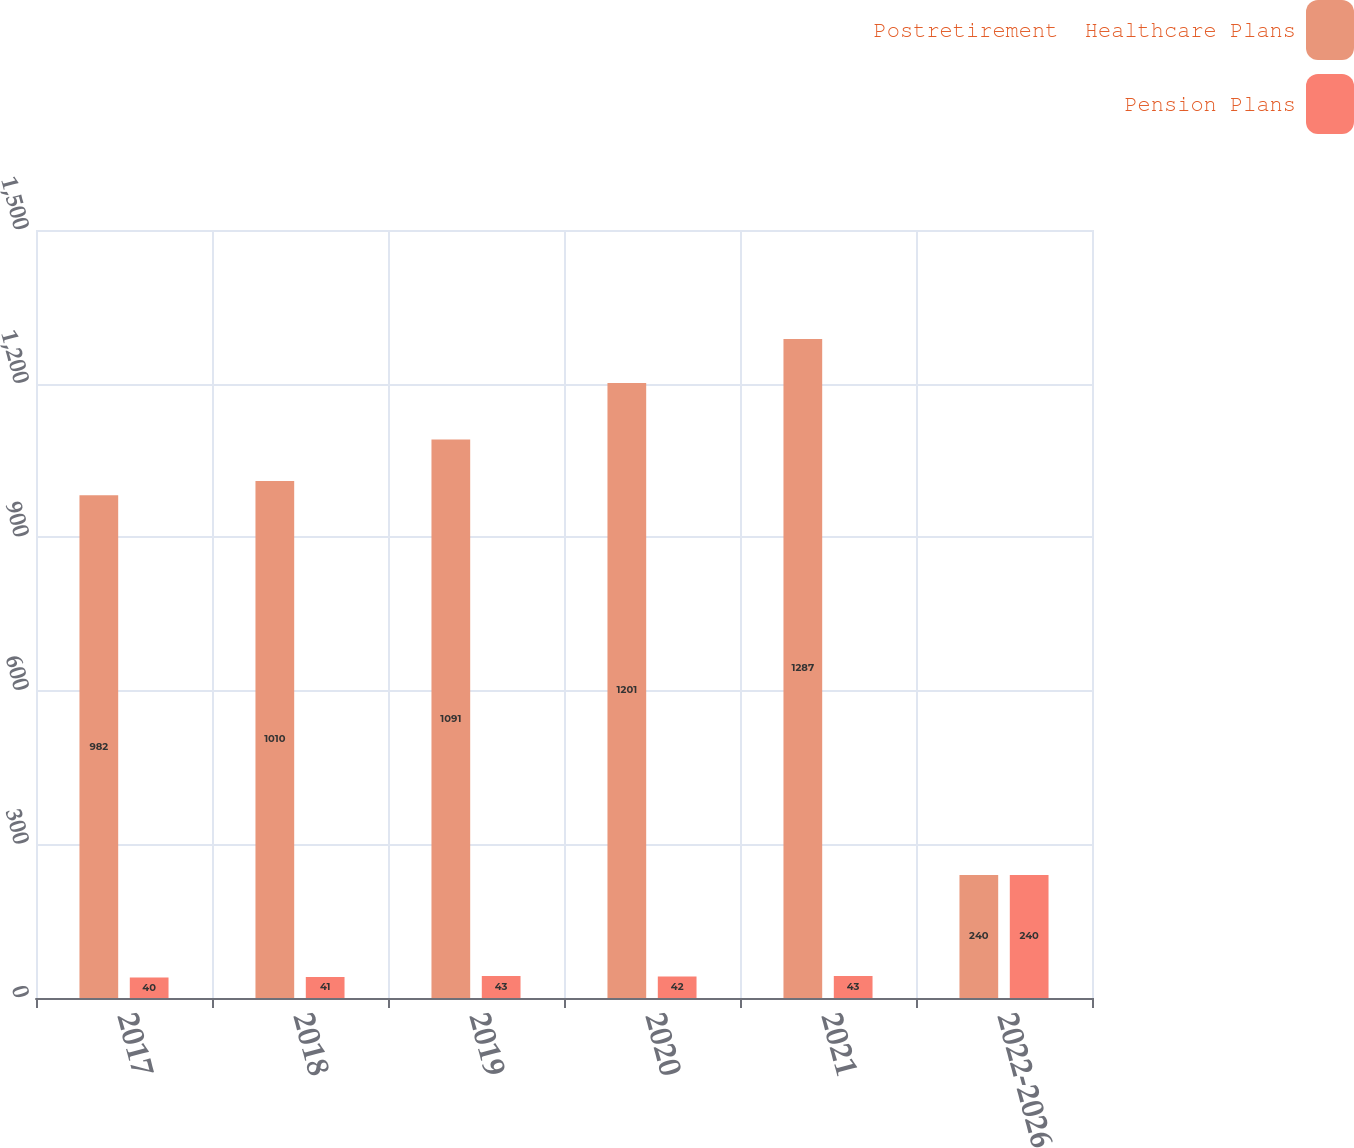Convert chart. <chart><loc_0><loc_0><loc_500><loc_500><stacked_bar_chart><ecel><fcel>2017<fcel>2018<fcel>2019<fcel>2020<fcel>2021<fcel>2022-2026<nl><fcel>Postretirement  Healthcare Plans<fcel>982<fcel>1010<fcel>1091<fcel>1201<fcel>1287<fcel>240<nl><fcel>Pension Plans<fcel>40<fcel>41<fcel>43<fcel>42<fcel>43<fcel>240<nl></chart> 